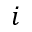<formula> <loc_0><loc_0><loc_500><loc_500>i</formula> 